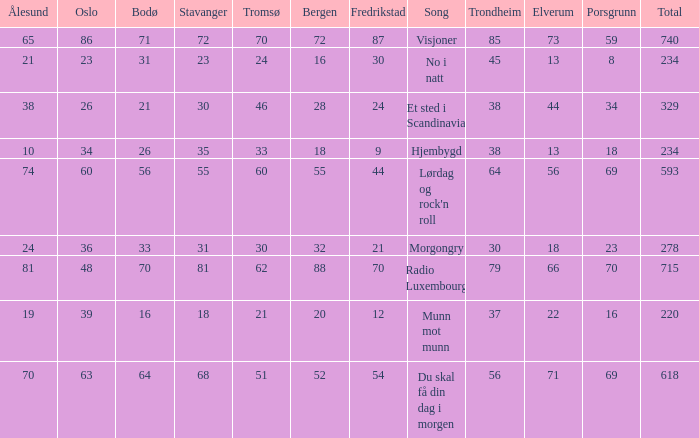What was the total for radio luxembourg? 715.0. 